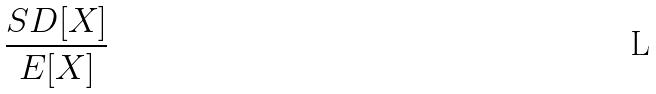<formula> <loc_0><loc_0><loc_500><loc_500>\frac { S D [ X ] } { E [ X ] }</formula> 